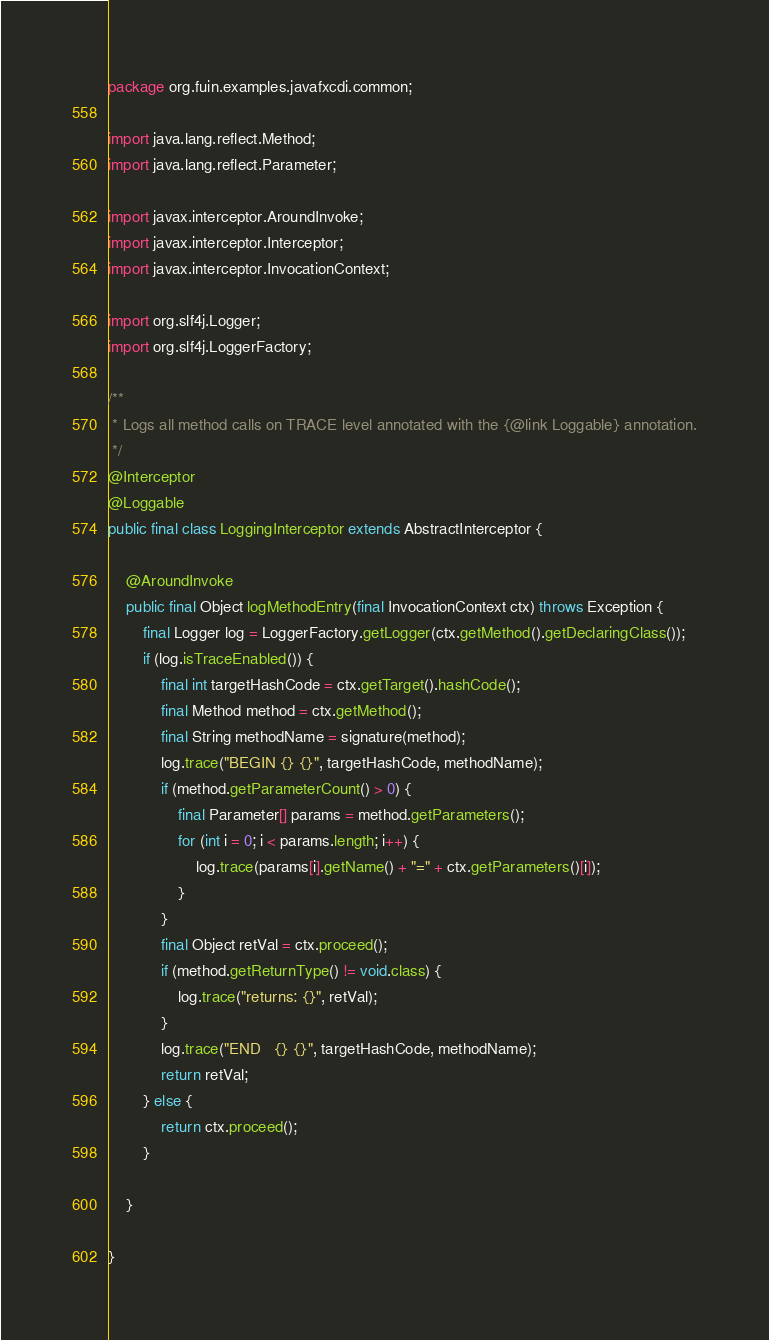Convert code to text. <code><loc_0><loc_0><loc_500><loc_500><_Java_>package org.fuin.examples.javafxcdi.common;

import java.lang.reflect.Method;
import java.lang.reflect.Parameter;

import javax.interceptor.AroundInvoke;
import javax.interceptor.Interceptor;
import javax.interceptor.InvocationContext;

import org.slf4j.Logger;
import org.slf4j.LoggerFactory;

/**
 * Logs all method calls on TRACE level annotated with the {@link Loggable} annotation.
 */
@Interceptor
@Loggable
public final class LoggingInterceptor extends AbstractInterceptor {

    @AroundInvoke
    public final Object logMethodEntry(final InvocationContext ctx) throws Exception {
        final Logger log = LoggerFactory.getLogger(ctx.getMethod().getDeclaringClass());
        if (log.isTraceEnabled()) {
            final int targetHashCode = ctx.getTarget().hashCode();
            final Method method = ctx.getMethod();
            final String methodName = signature(method);
            log.trace("BEGIN {} {}", targetHashCode, methodName);
            if (method.getParameterCount() > 0) {
                final Parameter[] params = method.getParameters();
                for (int i = 0; i < params.length; i++) {
                    log.trace(params[i].getName() + "=" + ctx.getParameters()[i]);
                }
            }
            final Object retVal = ctx.proceed();
            if (method.getReturnType() != void.class) {
                log.trace("returns: {}", retVal);
            }
            log.trace("END   {} {}", targetHashCode, methodName);
            return retVal;
        } else {
            return ctx.proceed();
        }

    }

}
</code> 